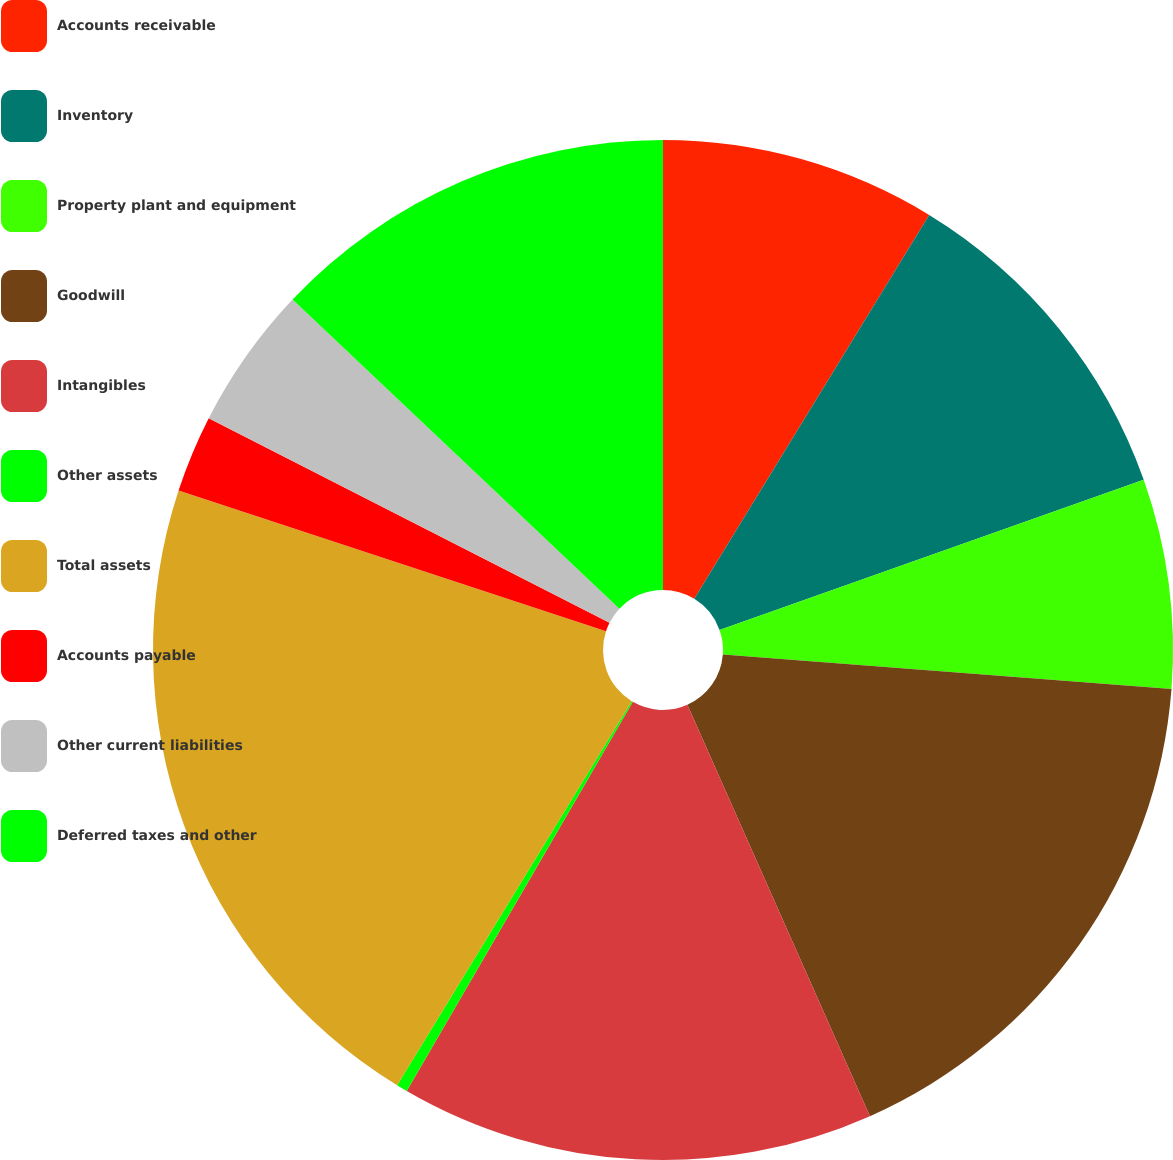Convert chart. <chart><loc_0><loc_0><loc_500><loc_500><pie_chart><fcel>Accounts receivable<fcel>Inventory<fcel>Property plant and equipment<fcel>Goodwill<fcel>Intangibles<fcel>Other assets<fcel>Total assets<fcel>Accounts payable<fcel>Other current liabilities<fcel>Deferred taxes and other<nl><fcel>8.74%<fcel>10.84%<fcel>6.64%<fcel>17.13%<fcel>15.03%<fcel>0.35%<fcel>21.33%<fcel>2.45%<fcel>4.55%<fcel>12.94%<nl></chart> 